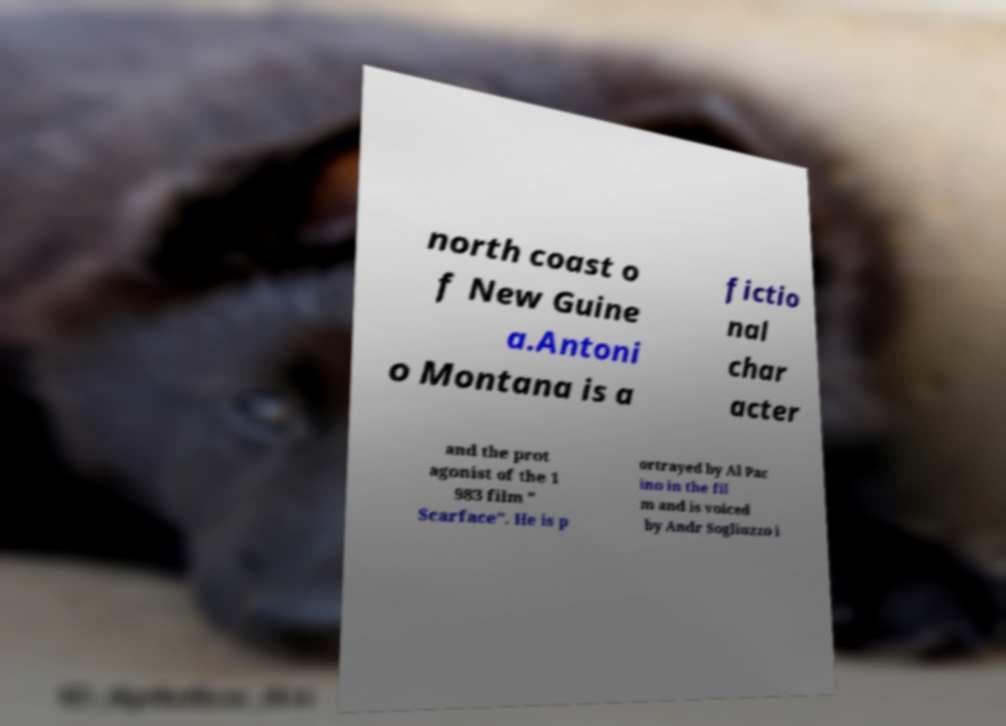I need the written content from this picture converted into text. Can you do that? north coast o f New Guine a.Antoni o Montana is a fictio nal char acter and the prot agonist of the 1 983 film " Scarface". He is p ortrayed by Al Pac ino in the fil m and is voiced by Andr Sogliuzzo i 